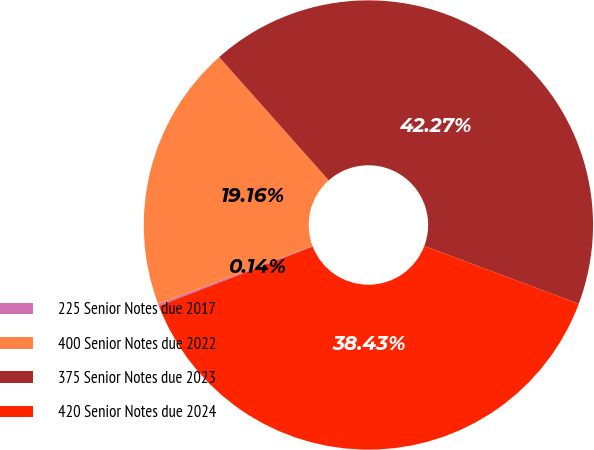<chart> <loc_0><loc_0><loc_500><loc_500><pie_chart><fcel>225 Senior Notes due 2017<fcel>400 Senior Notes due 2022<fcel>375 Senior Notes due 2023<fcel>420 Senior Notes due 2024<nl><fcel>0.14%<fcel>19.16%<fcel>42.27%<fcel>38.43%<nl></chart> 